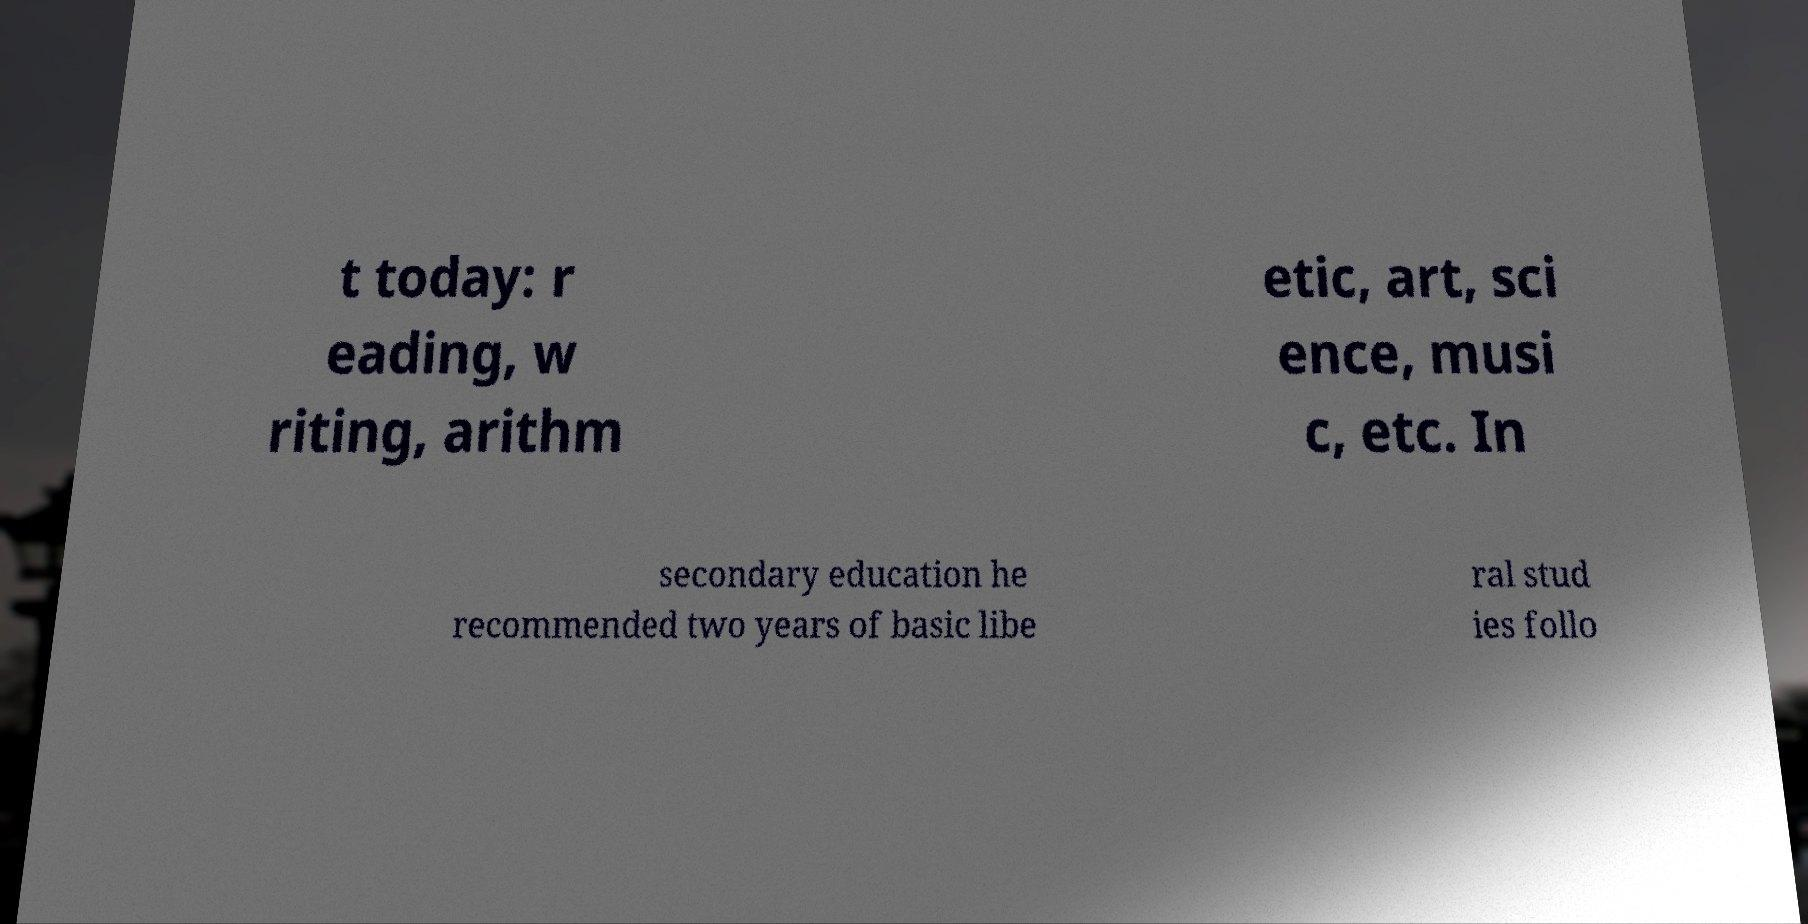Could you extract and type out the text from this image? t today: r eading, w riting, arithm etic, art, sci ence, musi c, etc. In secondary education he recommended two years of basic libe ral stud ies follo 